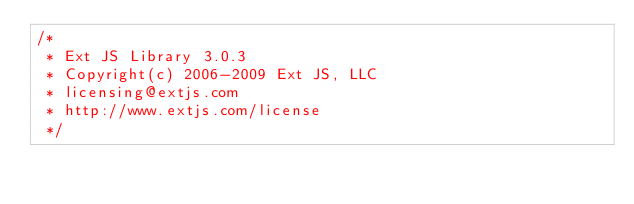Convert code to text. <code><loc_0><loc_0><loc_500><loc_500><_JavaScript_>/*
 * Ext JS Library 3.0.3
 * Copyright(c) 2006-2009 Ext JS, LLC
 * licensing@extjs.com
 * http://www.extjs.com/license
 */</code> 